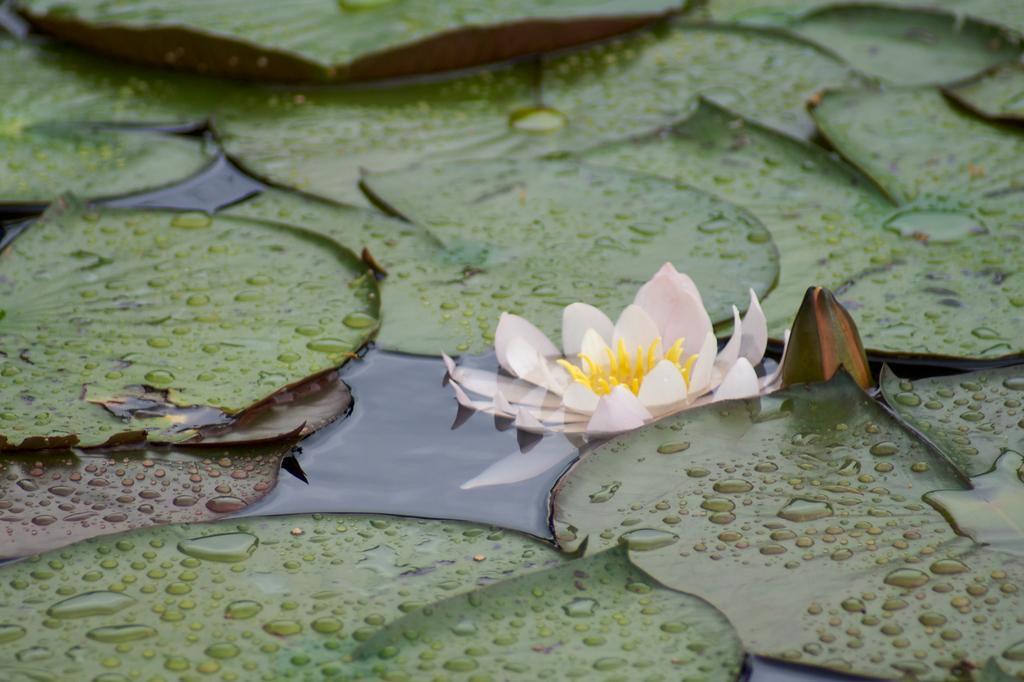How would you summarize this image in a sentence or two? In this image I can see the flower in yellow and lite pink color and I can see few leaves on the water and the leaves are in green color. 